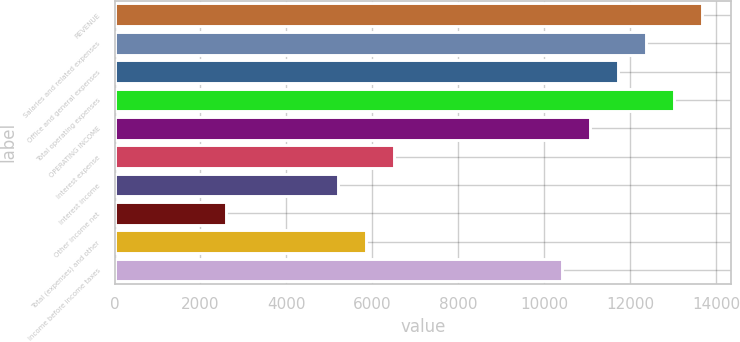Convert chart to OTSL. <chart><loc_0><loc_0><loc_500><loc_500><bar_chart><fcel>REVENUE<fcel>Salaries and related expenses<fcel>Office and general expenses<fcel>Total operating expenses<fcel>OPERATING INCOME<fcel>Interest expense<fcel>Interest income<fcel>Other income net<fcel>Total (expenses) and other<fcel>Income before income taxes<nl><fcel>13664.8<fcel>12363.4<fcel>11712.7<fcel>13014.1<fcel>11062<fcel>6507.27<fcel>5205.91<fcel>2603.19<fcel>5856.59<fcel>10411.4<nl></chart> 